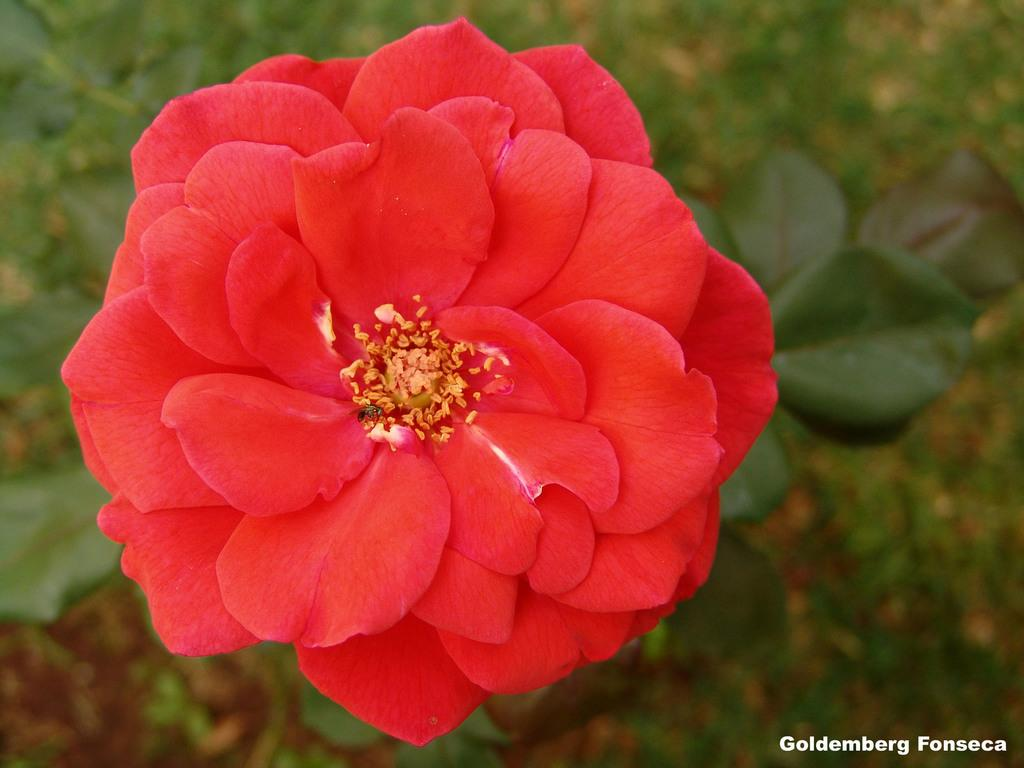What is the main subject of the image? There is a flower in the image. What else can be seen in the image besides the flower? There are leaves in the image. Is there any text present in the image? Yes, there is text in the bottom right of the image. How would you describe the background of the image? The background of the image is blurred. How many legs does the flower have in the image? Flowers do not have legs, so this question cannot be answered. 